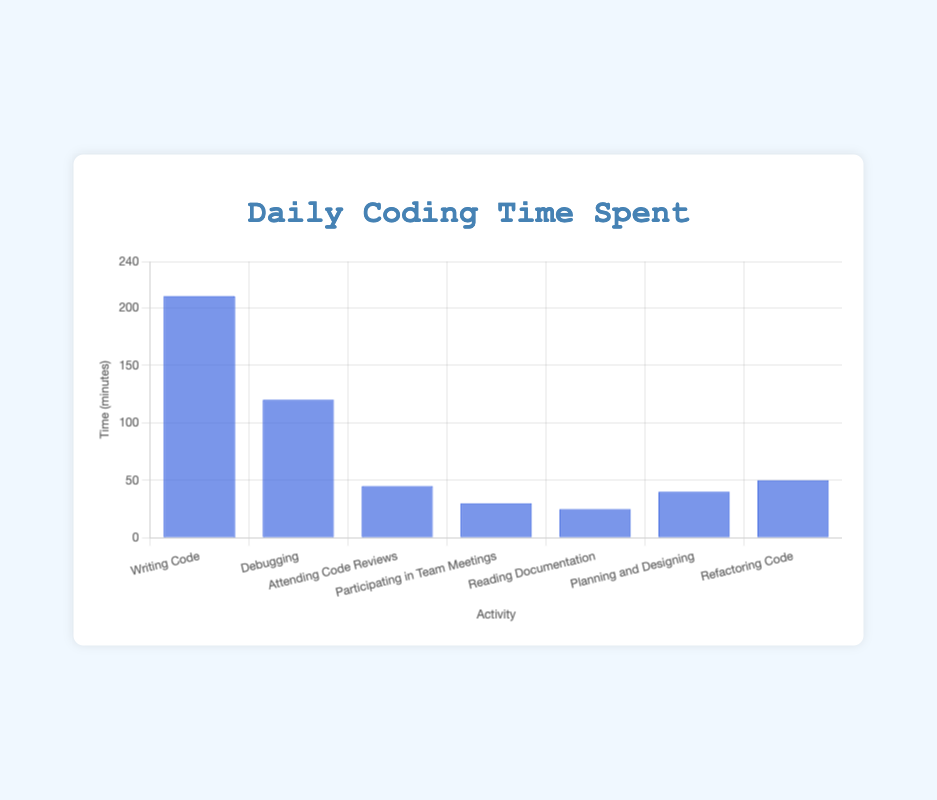What activity occupies the most time in minutes? Look at the bar heights to determine which activity has the tallest bar, which indicates the highest time spent on that activity. "Writing Code" is the tallest bar at 210 minutes.
Answer: Writing Code What is the total time spent on activities other than writing code? Sum up the times for all activities except "Writing Code": 120 (Debugging) + 45 (Attending Code Reviews) + 30 (Participating in Team Meetings) + 25 (Reading Documentation) + 40 (Planning and Designing) + 50 (Refactoring Code) = 310 minutes.
Answer: 310 minutes Which activity is given the least amount of time? Identify the shortest bar in the chart, which represents the activity with the least time. "Reading Documentation" is the shortest bar at 25 minutes.
Answer: Reading Documentation How much more time is spent debugging compared to planning and designing? Find the difference between the time spent on "Debugging" and "Planning and Designing": 120 (Debugging) - 40 (Planning and Designing) = 80 minutes.
Answer: 80 minutes What's the combined time spent on attending code reviews and participating in team meetings? Add the times for "Attending Code Reviews" and "Participating in Team Meetings": 45 (Attending Code Reviews) + 30 (Participating in Team Meetings) = 75 minutes.
Answer: 75 minutes Does refactoring code take more time than reading documentation? If so, by how much? Subtract the time spent on "Reading Documentation" from the time spent on "Refactoring Code": 50 - 25 = 25 minutes.
Answer: Yes, by 25 minutes Which activities combined take more time than writing code? Compare the time of "Writing Code" with the sum of other activities. "Writing Code" is 210 minutes. The sum of other activities is 120 (Debugging) + 45 (Attending Code Reviews) + 30 (Participating in Team Meetings) + 25 (Reading Documentation) + 40 (Planning and Designing) + 50 (Refactoring Code) = 310 minutes, which is greater than 210 minutes.
Answer: All other activities combined What percentage of the total daily coding time is spent on debugging? Calculate the total time first: 210 + 120 + 45 + 30 + 25 + 40 + 50 = 520 minutes. Then, find the percentage for debugging: (120/520) * 100 ≈ 23.08%.
Answer: 23.08% Which two activities, when combined, result in a total time closest to 100 minutes? Find pairs of activities whose times add up close to 100 minutes. "Attending Code Reviews" (45) + "Planning and Designing" (40) = 85 minutes, and "Participating in Team Meetings" (30) + "Refactoring Code" (50) = 80 minutes. The combination of "Attending Code Reviews" and "Participating in Team Meetings" = 45 + 30 = 75 minutes. The closest combination is "Participating in Team Meetings" (30) + "Refactoring Code" (50) which is 80 minutes.
Answer: Participating in Team Meetings and Refactoring Code 